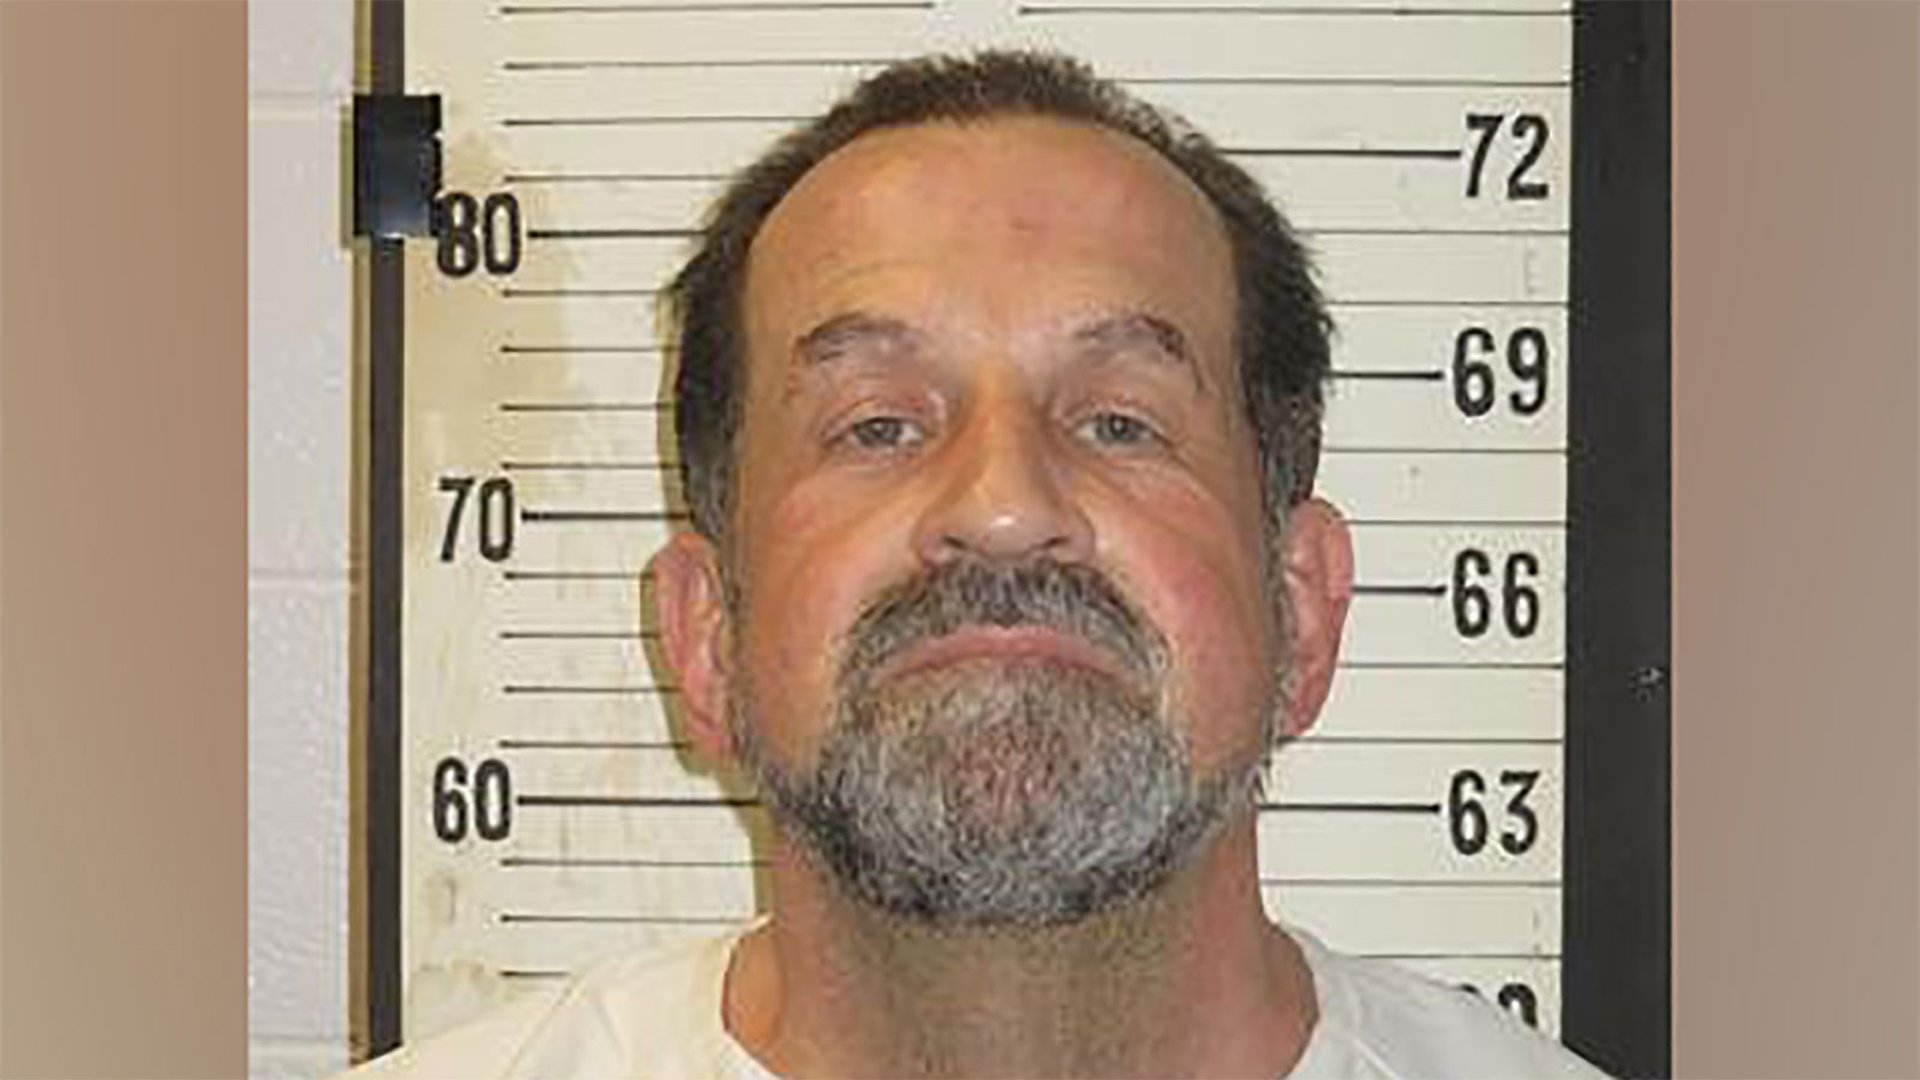Imagine a story where this man is the protagonist. Can you write the opening paragraph? In the dimly lit interrogation room of the old precinct, John Stevens sat with an air of defiance. The height chart behind him told tales of countless others who had stood in his place, but John was different. His steely eyes reflected years of hardship, yet they also held a spark of resilience. He wasn't there to beg or plead; he was there to fight for the truth, a truth that had been obscured by layers of corruption and deceit. As the door creaked open, John knew this was just the beginning of a battle that would test the very limits of his endurance. Can you describe a pivotal moment in his story? In a darkened alley, the rain poured down relentlessly as John Stevens faced his adversary, a shadowy figure who had been the puppet master behind his wrongful accusations. The dim glow of a distant streetlamp cast eerie reflections on the wet ground, highlighting the tension between them. John, clutching the evidence that could clear his name, felt the weight of the world on his shoulders. The confrontation was inevitable; he knew that this moment was his only chance to expose the truth and dismantle the nefarious network that had corrupted every layer of the city. With every ounce of courage and determination, John stepped forward, ready to reclaim his life and fight for justice. 